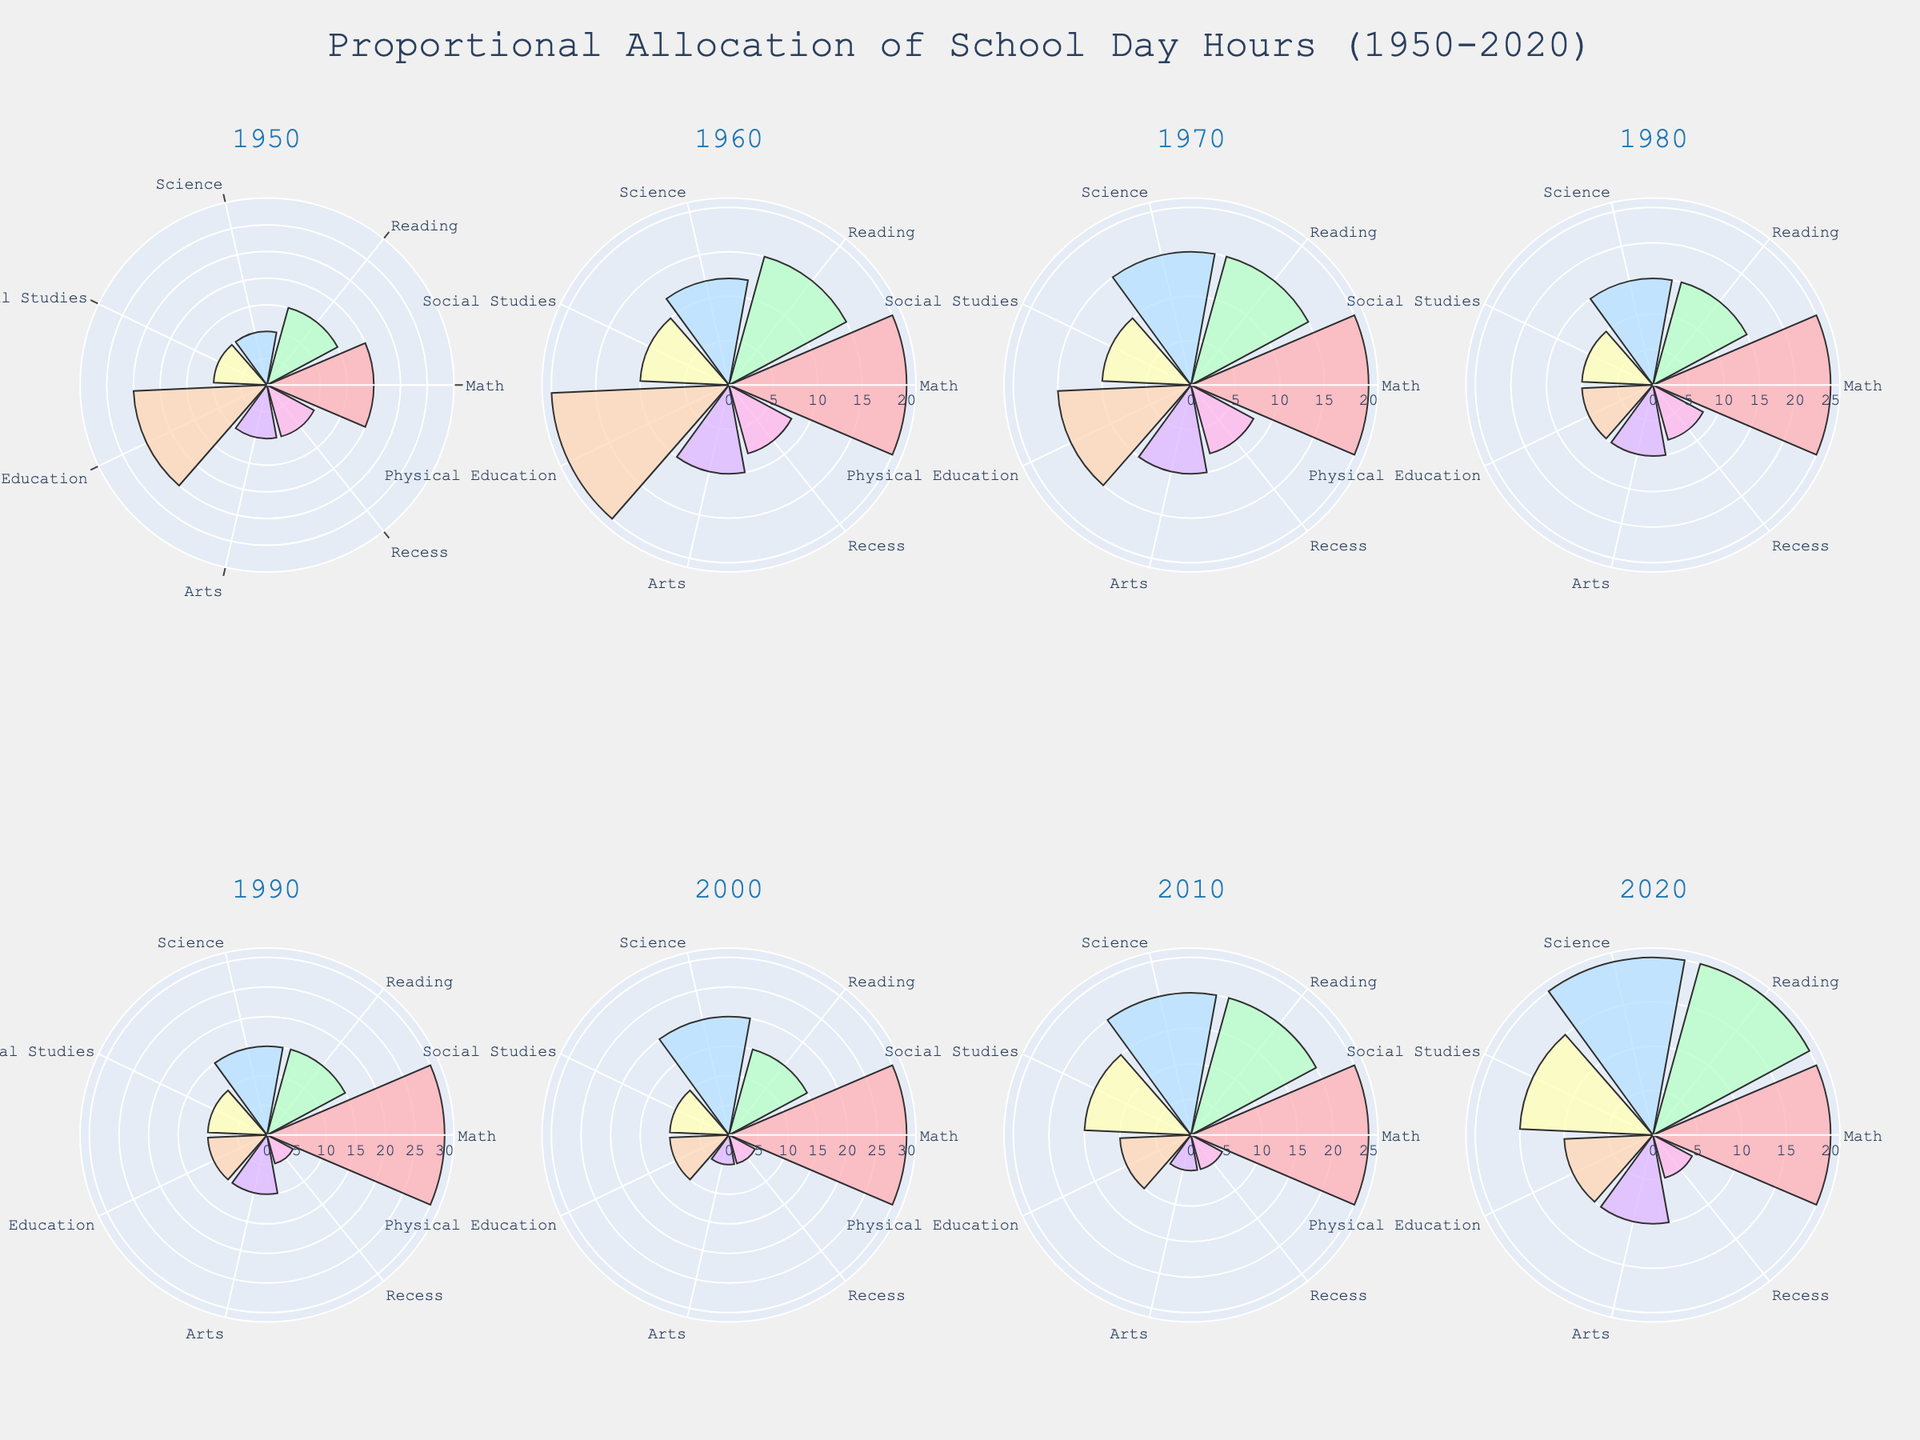What title is displayed on the figure? The figure title is visible at the top and reads "Proportional Allocation of School Day Hours (1950-2020)". This summarizes the overall theme of the plot and provides context for the data.
Answer: Proportional Allocation of School Day Hours (1950-2020) How many polar subplots are presented in the figure? By examining the arrangement of the subplots, it is clear that the figure is divided into two rows and four columns of polar plots, thus making a total of eight subplots.
Answer: 8 Which activity took the most proportional time in 1950? In the 1950 subplot, by comparing the lengths of the bars in the polar chart, Physical Education stands out as the longest, thus taking the most time.
Answer: Physical Education What activity had the smallest proportional change from 1950 to 2020? Observing the changes across the subplots from 1950 to 2020, it is evident that Social Studies had minimal change, remaining constant at about 10-15%.
Answer: Social Studies Compare the time allocated to Math and Science in 2020. Which one is higher? In the subplot for 2020, the bars for Math and Science can be compared. The length of the Math bar is shorter than the Science bar, indicating more time spent on Science.
Answer: Science Which year showed the highest allocation for Reading? By checking the proportion of the bar for Reading across all years, 2010 and 2020 show the same allocation. Therefore, they both have the highest allocation for Reading.
Answer: 2010 and 2020 What was the trend in the allocation of time for Arts from 1950 to 2020? Following the bar lengths for Arts across the subplots from 1950 to 2020, the allocation had a period of decline but returned to the initial value by 2020.
Answer: Returned to original Calculate the total time allocated to Math, Reading, and Science in the year 2000. Adding the allocations for Math (30), Reading (15), and Science (20) in 2000 gives a total time of 30+15+20=65.
Answer: 65 Which activity had the most significant reduction in allocation from 1950 to 2020? Comparing the differences in bar lengths from 1950 to 2020 across activities, Physical Education had the most significant reduction from 25% to 10%.
Answer: Physical Education 